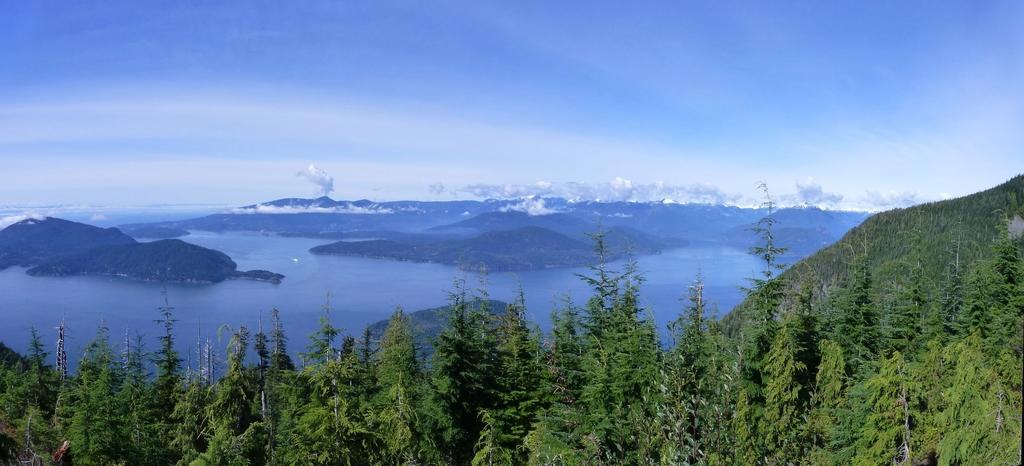In one or two sentences, can you explain what this image depicts? These are trees, this is water and a sky. 